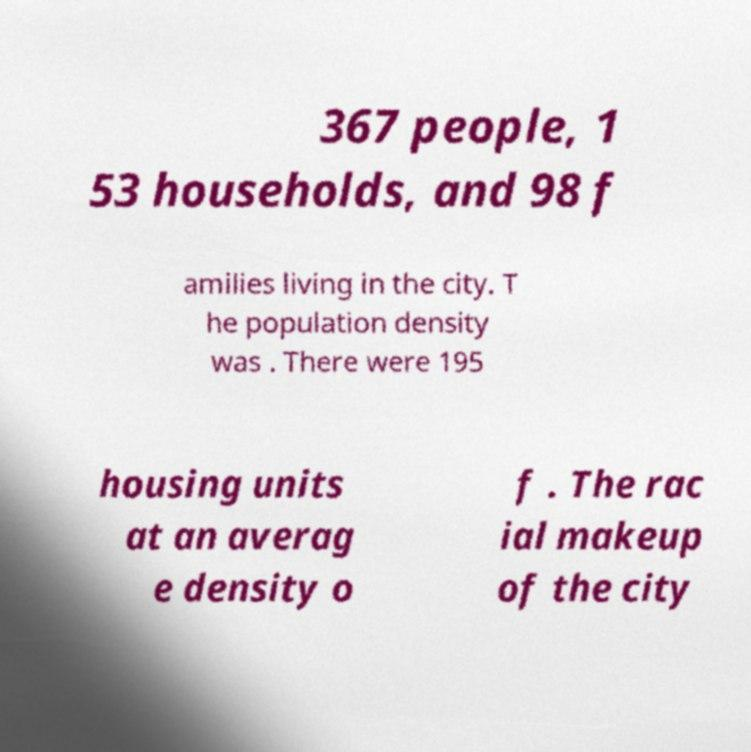I need the written content from this picture converted into text. Can you do that? 367 people, 1 53 households, and 98 f amilies living in the city. T he population density was . There were 195 housing units at an averag e density o f . The rac ial makeup of the city 